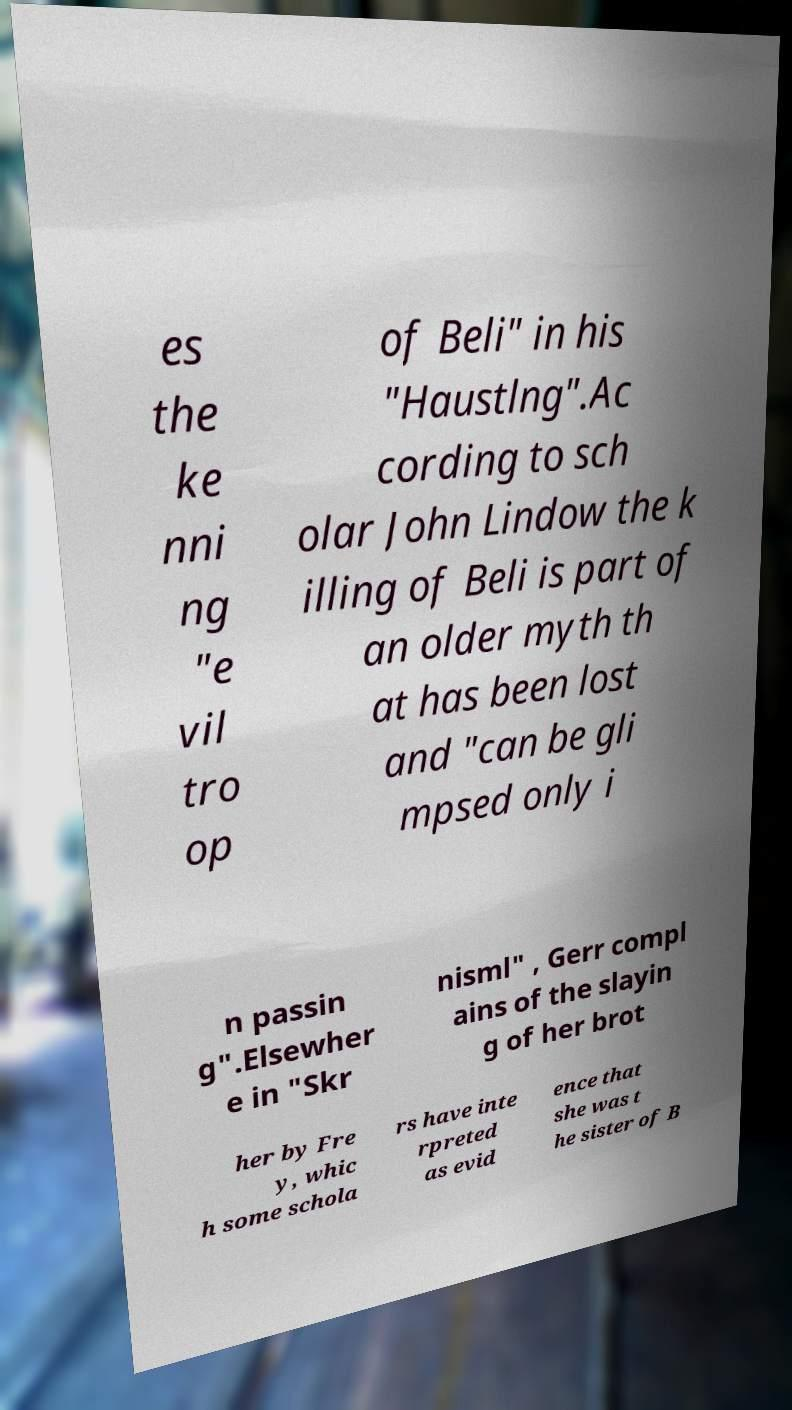What messages or text are displayed in this image? I need them in a readable, typed format. es the ke nni ng "e vil tro op of Beli" in his "Haustlng".Ac cording to sch olar John Lindow the k illing of Beli is part of an older myth th at has been lost and "can be gli mpsed only i n passin g".Elsewher e in "Skr nisml" , Gerr compl ains of the slayin g of her brot her by Fre y, whic h some schola rs have inte rpreted as evid ence that she was t he sister of B 